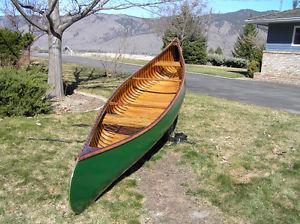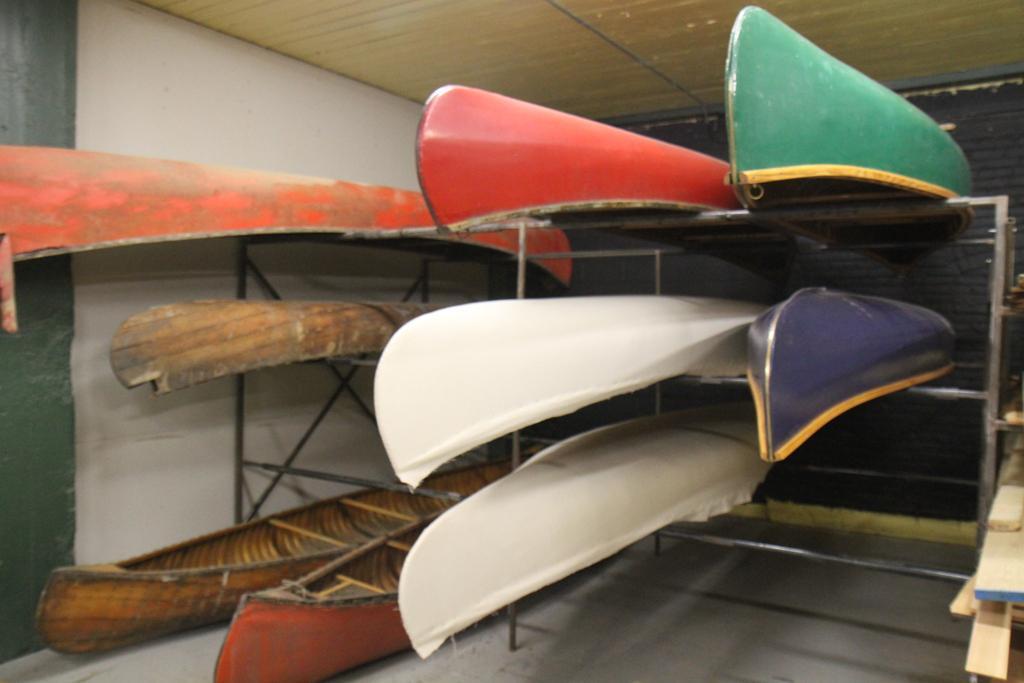The first image is the image on the left, the second image is the image on the right. Examine the images to the left and right. Is the description "There is at least one green canoe visible" accurate? Answer yes or no. Yes. The first image is the image on the left, the second image is the image on the right. Examine the images to the left and right. Is the description "In one image, multiple canoes are on an indoor rack, while in the other image, a single canoe is outside." accurate? Answer yes or no. Yes. 